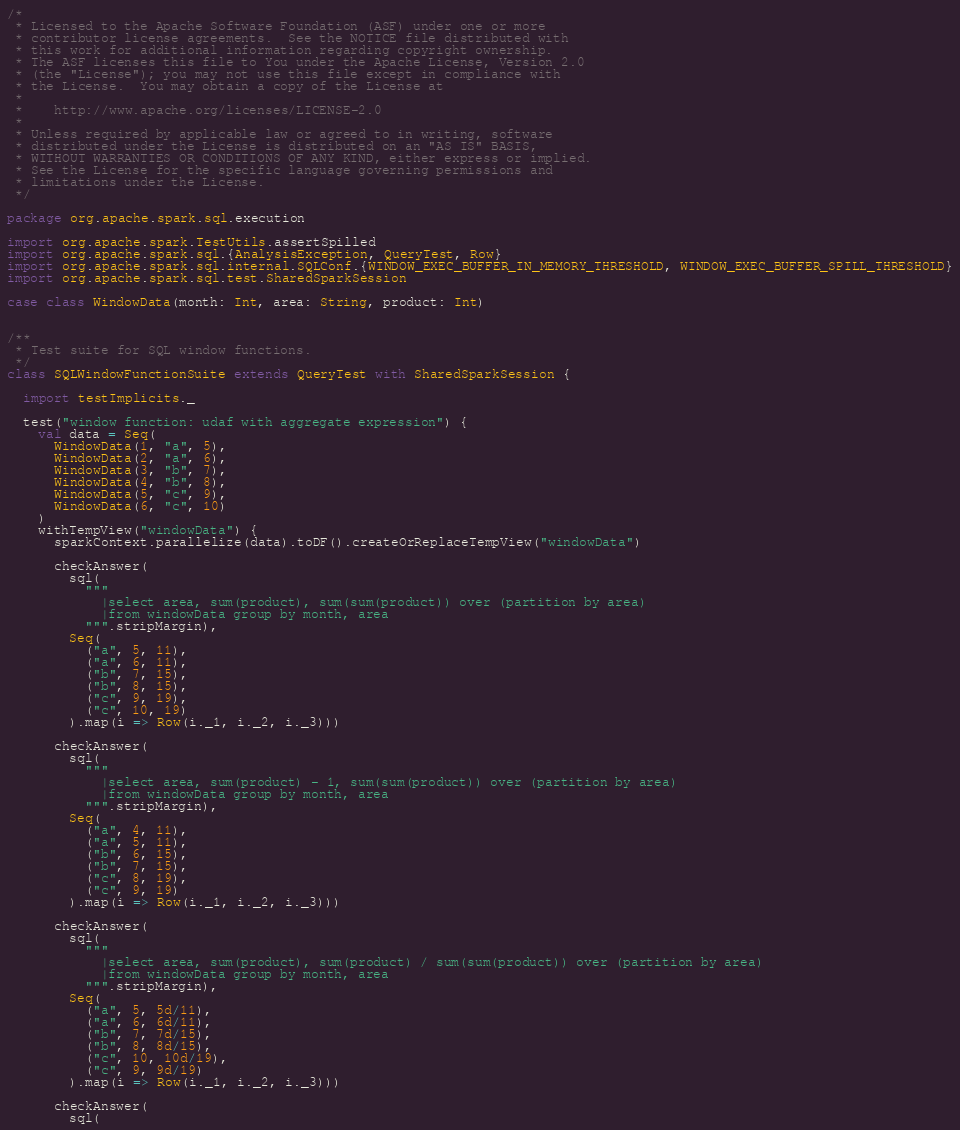<code> <loc_0><loc_0><loc_500><loc_500><_Scala_>/*
 * Licensed to the Apache Software Foundation (ASF) under one or more
 * contributor license agreements.  See the NOTICE file distributed with
 * this work for additional information regarding copyright ownership.
 * The ASF licenses this file to You under the Apache License, Version 2.0
 * (the "License"); you may not use this file except in compliance with
 * the License.  You may obtain a copy of the License at
 *
 *    http://www.apache.org/licenses/LICENSE-2.0
 *
 * Unless required by applicable law or agreed to in writing, software
 * distributed under the License is distributed on an "AS IS" BASIS,
 * WITHOUT WARRANTIES OR CONDITIONS OF ANY KIND, either express or implied.
 * See the License for the specific language governing permissions and
 * limitations under the License.
 */

package org.apache.spark.sql.execution

import org.apache.spark.TestUtils.assertSpilled
import org.apache.spark.sql.{AnalysisException, QueryTest, Row}
import org.apache.spark.sql.internal.SQLConf.{WINDOW_EXEC_BUFFER_IN_MEMORY_THRESHOLD, WINDOW_EXEC_BUFFER_SPILL_THRESHOLD}
import org.apache.spark.sql.test.SharedSparkSession

case class WindowData(month: Int, area: String, product: Int)


/**
 * Test suite for SQL window functions.
 */
class SQLWindowFunctionSuite extends QueryTest with SharedSparkSession {

  import testImplicits._

  test("window function: udaf with aggregate expression") {
    val data = Seq(
      WindowData(1, "a", 5),
      WindowData(2, "a", 6),
      WindowData(3, "b", 7),
      WindowData(4, "b", 8),
      WindowData(5, "c", 9),
      WindowData(6, "c", 10)
    )
    withTempView("windowData") {
      sparkContext.parallelize(data).toDF().createOrReplaceTempView("windowData")

      checkAnswer(
        sql(
          """
            |select area, sum(product), sum(sum(product)) over (partition by area)
            |from windowData group by month, area
          """.stripMargin),
        Seq(
          ("a", 5, 11),
          ("a", 6, 11),
          ("b", 7, 15),
          ("b", 8, 15),
          ("c", 9, 19),
          ("c", 10, 19)
        ).map(i => Row(i._1, i._2, i._3)))

      checkAnswer(
        sql(
          """
            |select area, sum(product) - 1, sum(sum(product)) over (partition by area)
            |from windowData group by month, area
          """.stripMargin),
        Seq(
          ("a", 4, 11),
          ("a", 5, 11),
          ("b", 6, 15),
          ("b", 7, 15),
          ("c", 8, 19),
          ("c", 9, 19)
        ).map(i => Row(i._1, i._2, i._3)))

      checkAnswer(
        sql(
          """
            |select area, sum(product), sum(product) / sum(sum(product)) over (partition by area)
            |from windowData group by month, area
          """.stripMargin),
        Seq(
          ("a", 5, 5d/11),
          ("a", 6, 6d/11),
          ("b", 7, 7d/15),
          ("b", 8, 8d/15),
          ("c", 10, 10d/19),
          ("c", 9, 9d/19)
        ).map(i => Row(i._1, i._2, i._3)))

      checkAnswer(
        sql(</code> 